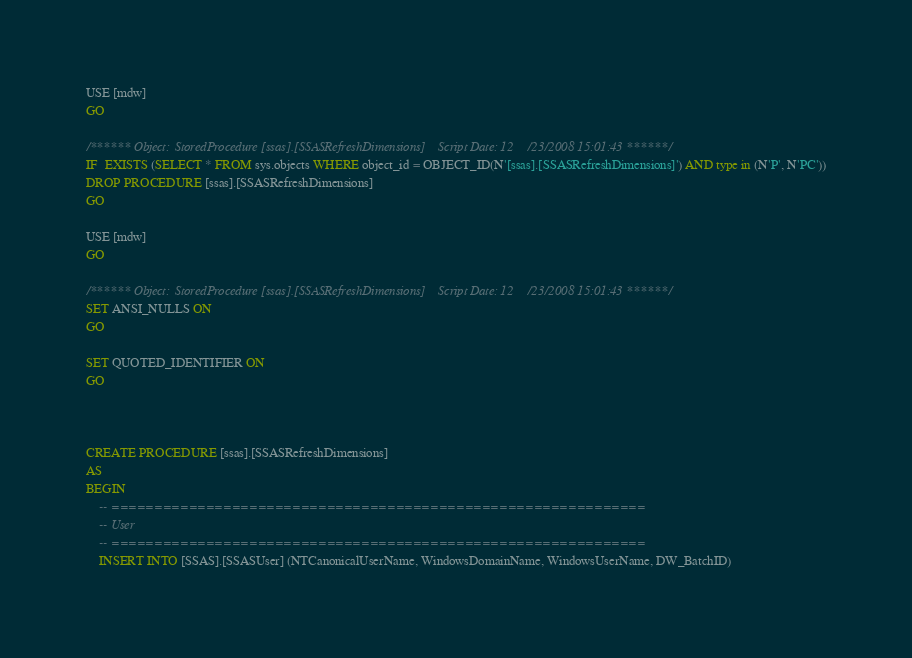Convert code to text. <code><loc_0><loc_0><loc_500><loc_500><_SQL_>USE [mdw]
GO

/****** Object:  StoredProcedure [ssas].[SSASRefreshDimensions]    Script Date: 12/23/2008 15:01:43 ******/
IF  EXISTS (SELECT * FROM sys.objects WHERE object_id = OBJECT_ID(N'[ssas].[SSASRefreshDimensions]') AND type in (N'P', N'PC'))
DROP PROCEDURE [ssas].[SSASRefreshDimensions]
GO

USE [mdw]
GO

/****** Object:  StoredProcedure [ssas].[SSASRefreshDimensions]    Script Date: 12/23/2008 15:01:43 ******/
SET ANSI_NULLS ON
GO

SET QUOTED_IDENTIFIER ON
GO



CREATE PROCEDURE [ssas].[SSASRefreshDimensions]
AS
BEGIN
	-- ==============================================================
	-- User 
	-- ==============================================================
	INSERT INTO [SSAS].[SSASUser] (NTCanonicalUserName, WindowsDomainName, WindowsUserName, DW_BatchID)</code> 